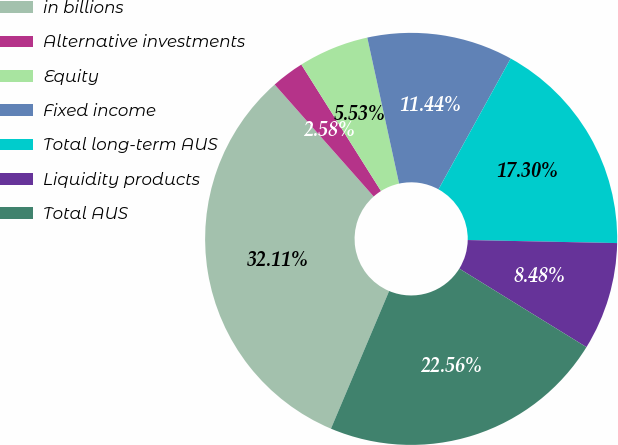<chart> <loc_0><loc_0><loc_500><loc_500><pie_chart><fcel>in billions<fcel>Alternative investments<fcel>Equity<fcel>Fixed income<fcel>Total long-term AUS<fcel>Liquidity products<fcel>Total AUS<nl><fcel>32.11%<fcel>2.58%<fcel>5.53%<fcel>11.44%<fcel>17.3%<fcel>8.48%<fcel>22.56%<nl></chart> 